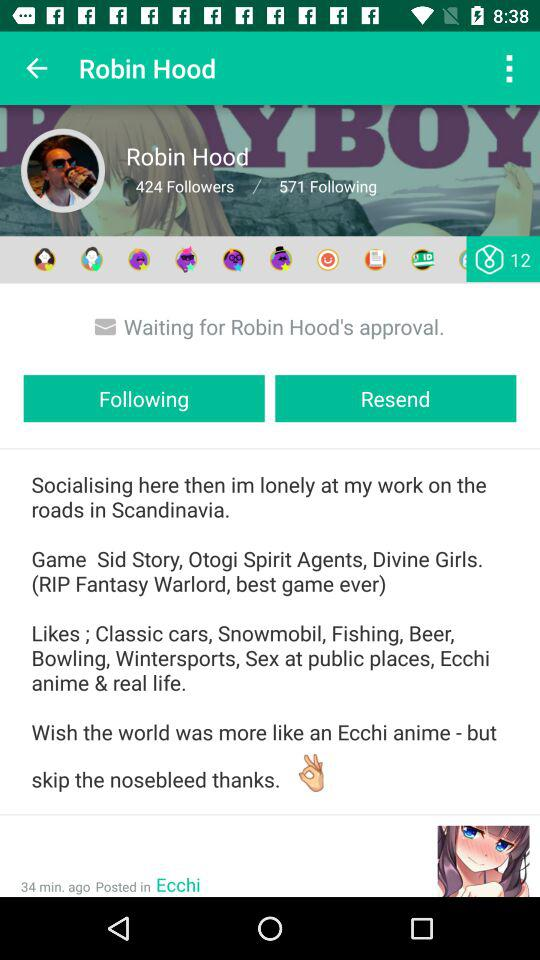How many followers does the user have? The user have 424 followers. 